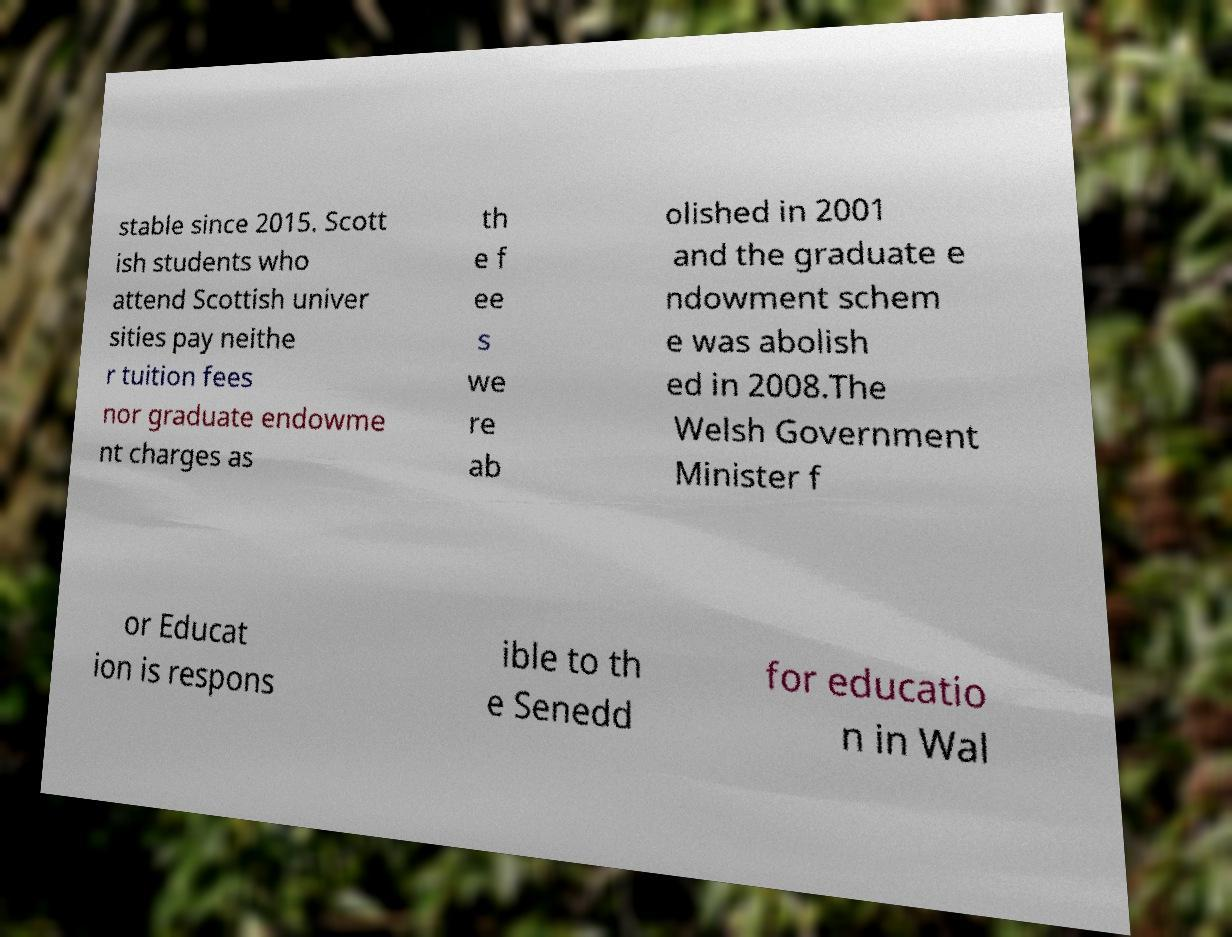Can you accurately transcribe the text from the provided image for me? stable since 2015. Scott ish students who attend Scottish univer sities pay neithe r tuition fees nor graduate endowme nt charges as th e f ee s we re ab olished in 2001 and the graduate e ndowment schem e was abolish ed in 2008.The Welsh Government Minister f or Educat ion is respons ible to th e Senedd for educatio n in Wal 